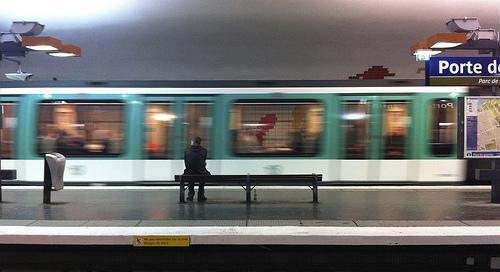How many people are on the bench?
Give a very brief answer. 1. 